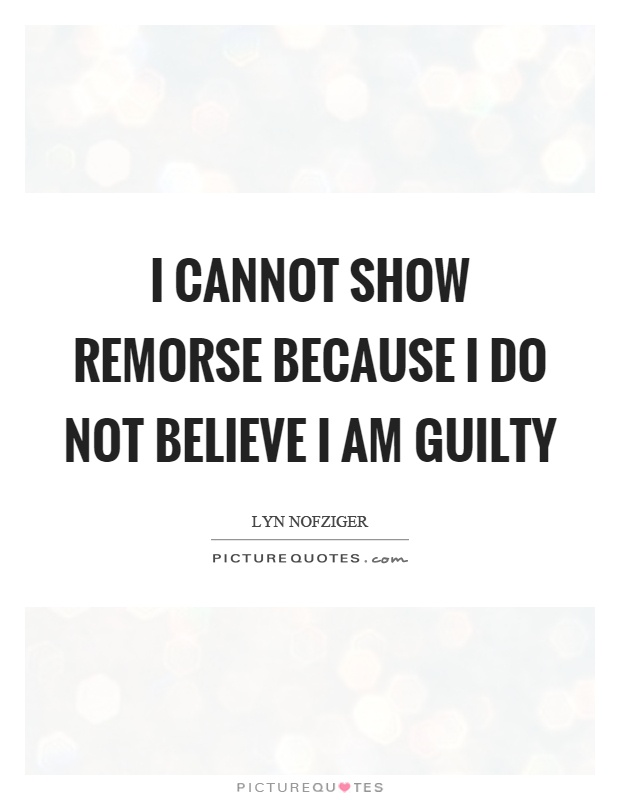Can the quote in this image resonate with different age groups or is it targeted towards a specific demographic? The universality and philosophical nature of the quote 'I cannot show remorse because I do not believe I am guilty' allows it to resonate across a wide range of age groups. However, the sophisticated style of the text presentation might particularly appeal to a more mature audience who are likely to engage more deeply with its implications about guilt and self-perception. Younger audiences could interpret it differently, perhaps focusing on its defiance or the bold assertion of self-belief, thus reflecting its versatile appeal. 